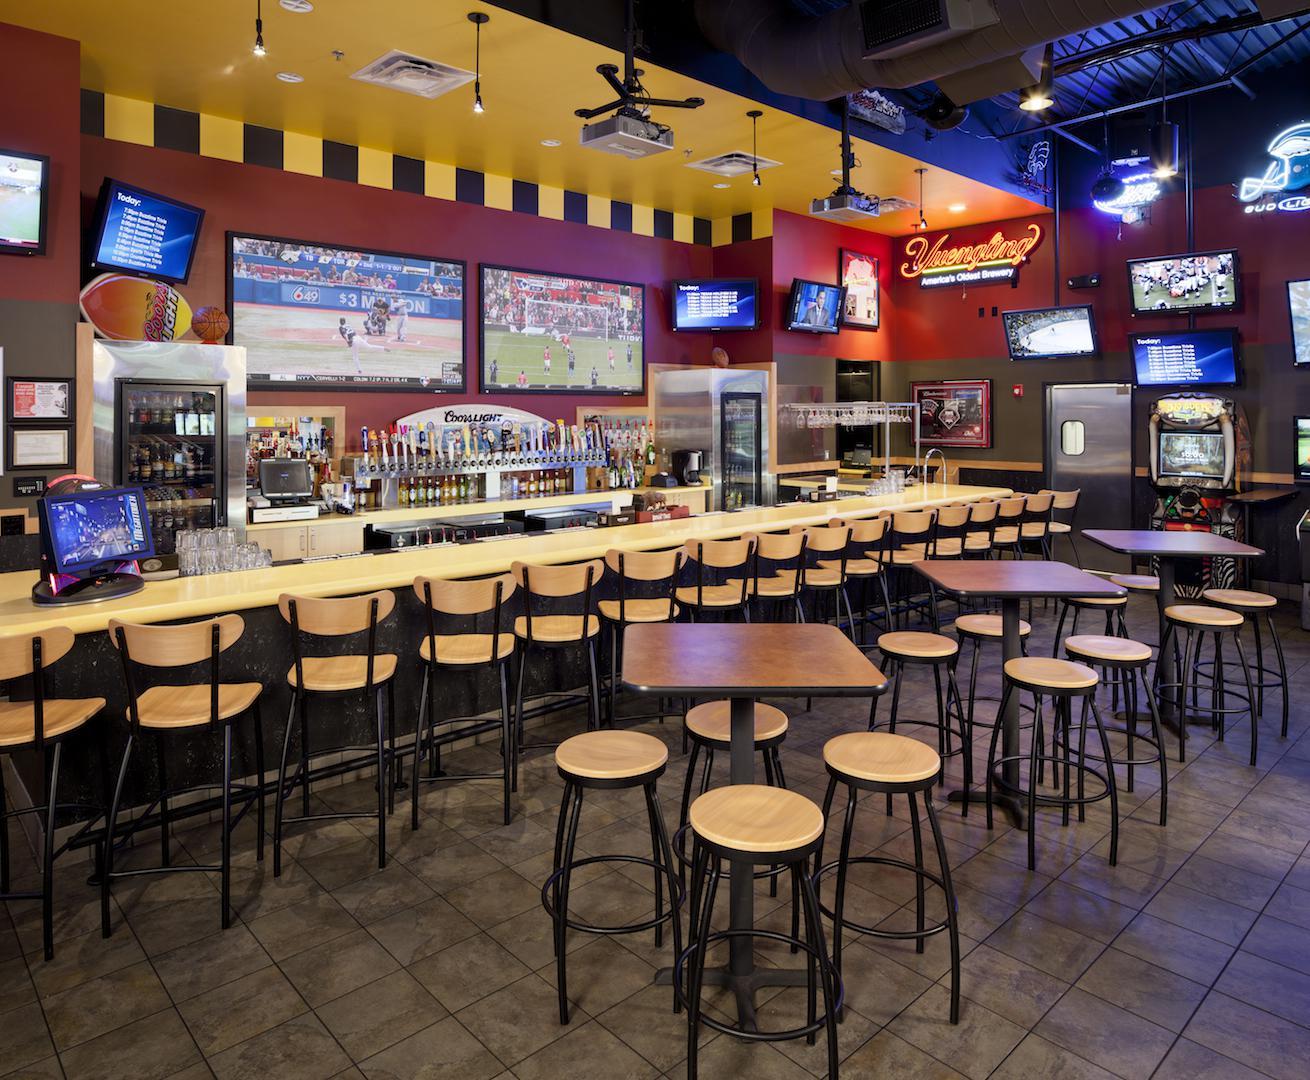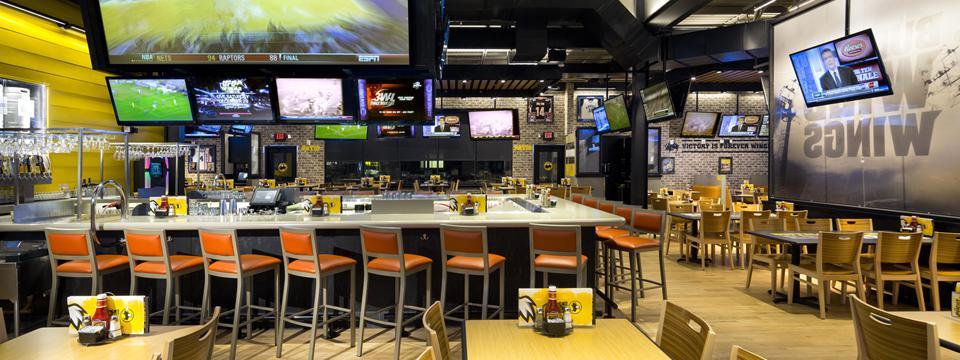The first image is the image on the left, the second image is the image on the right. Examine the images to the left and right. Is the description "Right image shows a bar with an American flag high on the wall near multiple TV screens." accurate? Answer yes or no. No. The first image is the image on the left, the second image is the image on the right. Analyze the images presented: Is the assertion "There are no people in either image." valid? Answer yes or no. Yes. 